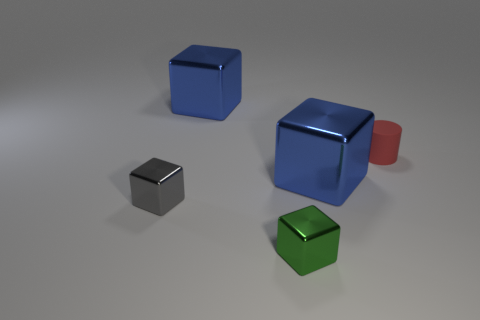Are there any big shiny blocks right of the red thing?
Keep it short and to the point. No. What is the color of the thing that is on the right side of the green shiny block and in front of the red cylinder?
Provide a short and direct response. Blue. What size is the metallic cube in front of the small metal object behind the small green shiny thing?
Offer a terse response. Small. How many spheres are metal things or tiny gray shiny objects?
Keep it short and to the point. 0. What is the color of the other cube that is the same size as the green metallic block?
Your response must be concise. Gray. What is the shape of the large thing that is in front of the shiny cube behind the red object?
Your answer should be compact. Cube. Is the size of the blue thing in front of the matte object the same as the rubber object?
Offer a very short reply. No. How many other things are there of the same material as the green thing?
Your answer should be very brief. 3. What number of red objects are large objects or small things?
Your answer should be compact. 1. What number of tiny green objects are behind the tiny red rubber cylinder?
Make the answer very short. 0. 